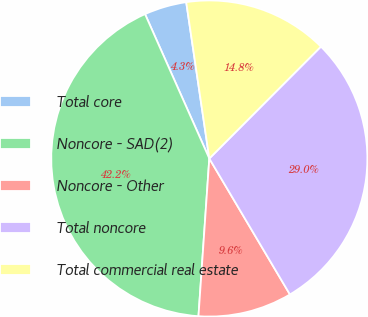Convert chart to OTSL. <chart><loc_0><loc_0><loc_500><loc_500><pie_chart><fcel>Total core<fcel>Noncore - SAD(2)<fcel>Noncore - Other<fcel>Total noncore<fcel>Total commercial real estate<nl><fcel>4.33%<fcel>42.24%<fcel>9.61%<fcel>29.0%<fcel>14.81%<nl></chart> 